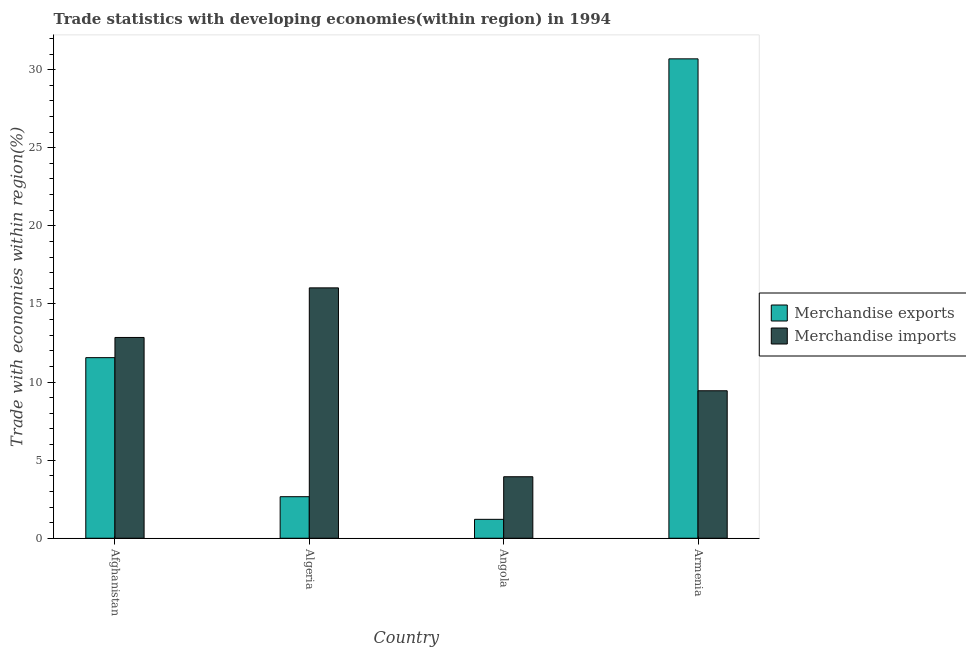How many groups of bars are there?
Give a very brief answer. 4. Are the number of bars per tick equal to the number of legend labels?
Offer a very short reply. Yes. How many bars are there on the 3rd tick from the left?
Offer a very short reply. 2. What is the label of the 1st group of bars from the left?
Provide a short and direct response. Afghanistan. What is the merchandise imports in Algeria?
Your answer should be very brief. 16.03. Across all countries, what is the maximum merchandise imports?
Ensure brevity in your answer.  16.03. Across all countries, what is the minimum merchandise imports?
Keep it short and to the point. 3.94. In which country was the merchandise exports maximum?
Keep it short and to the point. Armenia. In which country was the merchandise imports minimum?
Provide a succinct answer. Angola. What is the total merchandise exports in the graph?
Make the answer very short. 46.12. What is the difference between the merchandise imports in Angola and that in Armenia?
Your response must be concise. -5.5. What is the difference between the merchandise exports in Angola and the merchandise imports in Armenia?
Provide a short and direct response. -8.23. What is the average merchandise imports per country?
Give a very brief answer. 10.57. What is the difference between the merchandise imports and merchandise exports in Afghanistan?
Provide a succinct answer. 1.29. What is the ratio of the merchandise exports in Afghanistan to that in Armenia?
Provide a short and direct response. 0.38. Is the difference between the merchandise exports in Afghanistan and Armenia greater than the difference between the merchandise imports in Afghanistan and Armenia?
Your answer should be compact. No. What is the difference between the highest and the second highest merchandise exports?
Offer a very short reply. 19.13. What is the difference between the highest and the lowest merchandise imports?
Your response must be concise. 12.09. In how many countries, is the merchandise exports greater than the average merchandise exports taken over all countries?
Your answer should be compact. 2. Is the sum of the merchandise exports in Algeria and Armenia greater than the maximum merchandise imports across all countries?
Offer a very short reply. Yes. What does the 1st bar from the left in Armenia represents?
Provide a succinct answer. Merchandise exports. What is the title of the graph?
Your response must be concise. Trade statistics with developing economies(within region) in 1994. What is the label or title of the X-axis?
Provide a succinct answer. Country. What is the label or title of the Y-axis?
Your answer should be very brief. Trade with economies within region(%). What is the Trade with economies within region(%) of Merchandise exports in Afghanistan?
Offer a very short reply. 11.56. What is the Trade with economies within region(%) of Merchandise imports in Afghanistan?
Provide a succinct answer. 12.85. What is the Trade with economies within region(%) of Merchandise exports in Algeria?
Give a very brief answer. 2.66. What is the Trade with economies within region(%) of Merchandise imports in Algeria?
Offer a very short reply. 16.03. What is the Trade with economies within region(%) of Merchandise exports in Angola?
Make the answer very short. 1.21. What is the Trade with economies within region(%) in Merchandise imports in Angola?
Offer a very short reply. 3.94. What is the Trade with economies within region(%) of Merchandise exports in Armenia?
Your answer should be very brief. 30.69. What is the Trade with economies within region(%) in Merchandise imports in Armenia?
Provide a short and direct response. 9.44. Across all countries, what is the maximum Trade with economies within region(%) in Merchandise exports?
Provide a succinct answer. 30.69. Across all countries, what is the maximum Trade with economies within region(%) in Merchandise imports?
Keep it short and to the point. 16.03. Across all countries, what is the minimum Trade with economies within region(%) of Merchandise exports?
Ensure brevity in your answer.  1.21. Across all countries, what is the minimum Trade with economies within region(%) of Merchandise imports?
Give a very brief answer. 3.94. What is the total Trade with economies within region(%) in Merchandise exports in the graph?
Provide a short and direct response. 46.12. What is the total Trade with economies within region(%) of Merchandise imports in the graph?
Offer a terse response. 42.26. What is the difference between the Trade with economies within region(%) in Merchandise exports in Afghanistan and that in Algeria?
Offer a very short reply. 8.9. What is the difference between the Trade with economies within region(%) of Merchandise imports in Afghanistan and that in Algeria?
Your response must be concise. -3.17. What is the difference between the Trade with economies within region(%) in Merchandise exports in Afghanistan and that in Angola?
Make the answer very short. 10.35. What is the difference between the Trade with economies within region(%) in Merchandise imports in Afghanistan and that in Angola?
Keep it short and to the point. 8.92. What is the difference between the Trade with economies within region(%) in Merchandise exports in Afghanistan and that in Armenia?
Ensure brevity in your answer.  -19.13. What is the difference between the Trade with economies within region(%) of Merchandise imports in Afghanistan and that in Armenia?
Offer a very short reply. 3.41. What is the difference between the Trade with economies within region(%) of Merchandise exports in Algeria and that in Angola?
Make the answer very short. 1.45. What is the difference between the Trade with economies within region(%) in Merchandise imports in Algeria and that in Angola?
Make the answer very short. 12.09. What is the difference between the Trade with economies within region(%) in Merchandise exports in Algeria and that in Armenia?
Keep it short and to the point. -28.03. What is the difference between the Trade with economies within region(%) in Merchandise imports in Algeria and that in Armenia?
Keep it short and to the point. 6.59. What is the difference between the Trade with economies within region(%) of Merchandise exports in Angola and that in Armenia?
Make the answer very short. -29.48. What is the difference between the Trade with economies within region(%) in Merchandise imports in Angola and that in Armenia?
Provide a succinct answer. -5.5. What is the difference between the Trade with economies within region(%) of Merchandise exports in Afghanistan and the Trade with economies within region(%) of Merchandise imports in Algeria?
Offer a very short reply. -4.47. What is the difference between the Trade with economies within region(%) in Merchandise exports in Afghanistan and the Trade with economies within region(%) in Merchandise imports in Angola?
Offer a terse response. 7.62. What is the difference between the Trade with economies within region(%) of Merchandise exports in Afghanistan and the Trade with economies within region(%) of Merchandise imports in Armenia?
Make the answer very short. 2.12. What is the difference between the Trade with economies within region(%) in Merchandise exports in Algeria and the Trade with economies within region(%) in Merchandise imports in Angola?
Give a very brief answer. -1.28. What is the difference between the Trade with economies within region(%) in Merchandise exports in Algeria and the Trade with economies within region(%) in Merchandise imports in Armenia?
Your answer should be compact. -6.78. What is the difference between the Trade with economies within region(%) in Merchandise exports in Angola and the Trade with economies within region(%) in Merchandise imports in Armenia?
Your response must be concise. -8.23. What is the average Trade with economies within region(%) in Merchandise exports per country?
Offer a very short reply. 11.53. What is the average Trade with economies within region(%) of Merchandise imports per country?
Make the answer very short. 10.57. What is the difference between the Trade with economies within region(%) in Merchandise exports and Trade with economies within region(%) in Merchandise imports in Afghanistan?
Offer a terse response. -1.29. What is the difference between the Trade with economies within region(%) of Merchandise exports and Trade with economies within region(%) of Merchandise imports in Algeria?
Provide a succinct answer. -13.37. What is the difference between the Trade with economies within region(%) of Merchandise exports and Trade with economies within region(%) of Merchandise imports in Angola?
Your response must be concise. -2.73. What is the difference between the Trade with economies within region(%) in Merchandise exports and Trade with economies within region(%) in Merchandise imports in Armenia?
Offer a terse response. 21.25. What is the ratio of the Trade with economies within region(%) of Merchandise exports in Afghanistan to that in Algeria?
Your answer should be very brief. 4.35. What is the ratio of the Trade with economies within region(%) of Merchandise imports in Afghanistan to that in Algeria?
Keep it short and to the point. 0.8. What is the ratio of the Trade with economies within region(%) in Merchandise exports in Afghanistan to that in Angola?
Make the answer very short. 9.55. What is the ratio of the Trade with economies within region(%) of Merchandise imports in Afghanistan to that in Angola?
Make the answer very short. 3.26. What is the ratio of the Trade with economies within region(%) in Merchandise exports in Afghanistan to that in Armenia?
Ensure brevity in your answer.  0.38. What is the ratio of the Trade with economies within region(%) of Merchandise imports in Afghanistan to that in Armenia?
Give a very brief answer. 1.36. What is the ratio of the Trade with economies within region(%) of Merchandise exports in Algeria to that in Angola?
Provide a succinct answer. 2.2. What is the ratio of the Trade with economies within region(%) in Merchandise imports in Algeria to that in Angola?
Offer a very short reply. 4.07. What is the ratio of the Trade with economies within region(%) in Merchandise exports in Algeria to that in Armenia?
Your answer should be compact. 0.09. What is the ratio of the Trade with economies within region(%) in Merchandise imports in Algeria to that in Armenia?
Provide a short and direct response. 1.7. What is the ratio of the Trade with economies within region(%) of Merchandise exports in Angola to that in Armenia?
Your answer should be compact. 0.04. What is the ratio of the Trade with economies within region(%) of Merchandise imports in Angola to that in Armenia?
Make the answer very short. 0.42. What is the difference between the highest and the second highest Trade with economies within region(%) of Merchandise exports?
Ensure brevity in your answer.  19.13. What is the difference between the highest and the second highest Trade with economies within region(%) in Merchandise imports?
Your answer should be very brief. 3.17. What is the difference between the highest and the lowest Trade with economies within region(%) in Merchandise exports?
Provide a succinct answer. 29.48. What is the difference between the highest and the lowest Trade with economies within region(%) of Merchandise imports?
Ensure brevity in your answer.  12.09. 